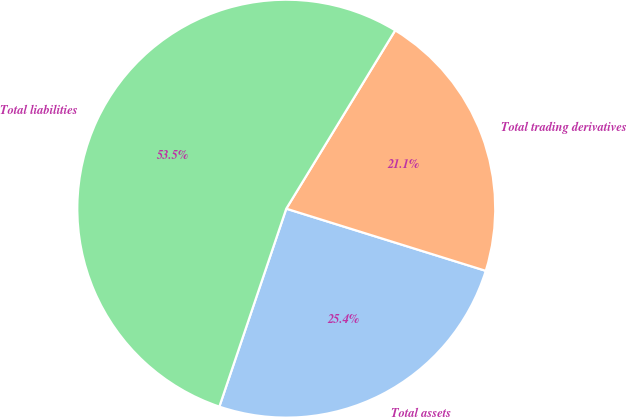Convert chart to OTSL. <chart><loc_0><loc_0><loc_500><loc_500><pie_chart><fcel>Total assets<fcel>Total trading derivatives<fcel>Total liabilities<nl><fcel>25.38%<fcel>21.08%<fcel>53.54%<nl></chart> 